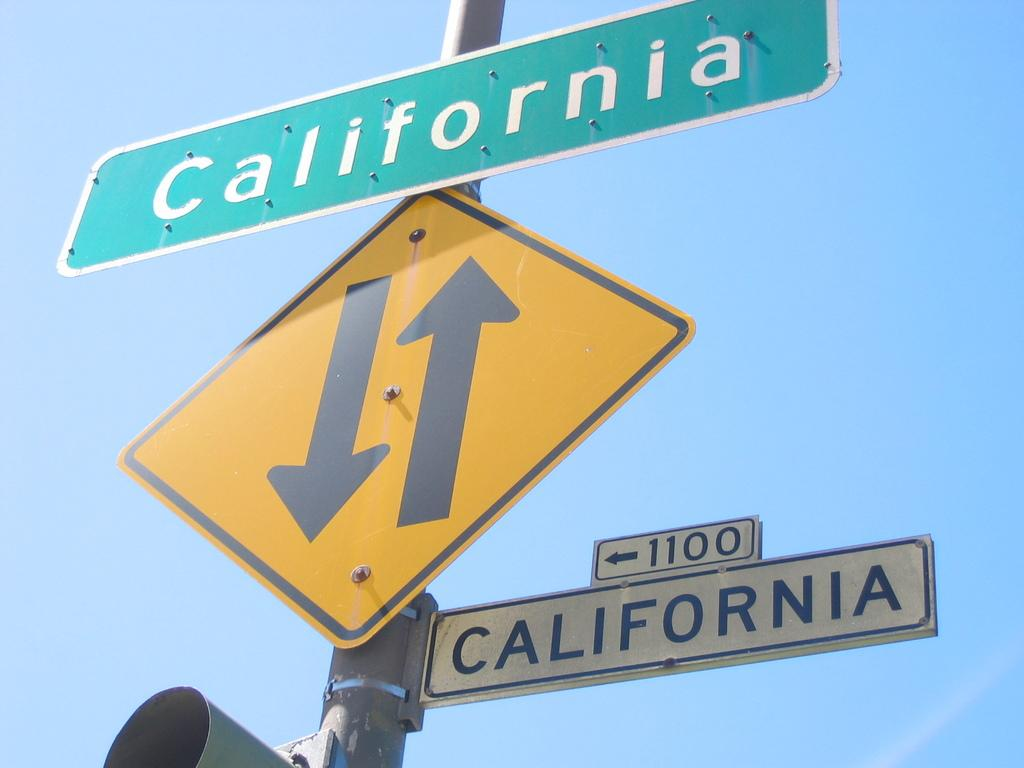<image>
Give a short and clear explanation of the subsequent image. Street name signs in white and green both shows California as the name. 